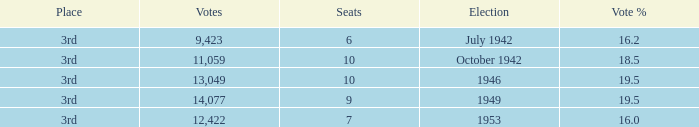Name the most vote % with election of 1946 19.5. 